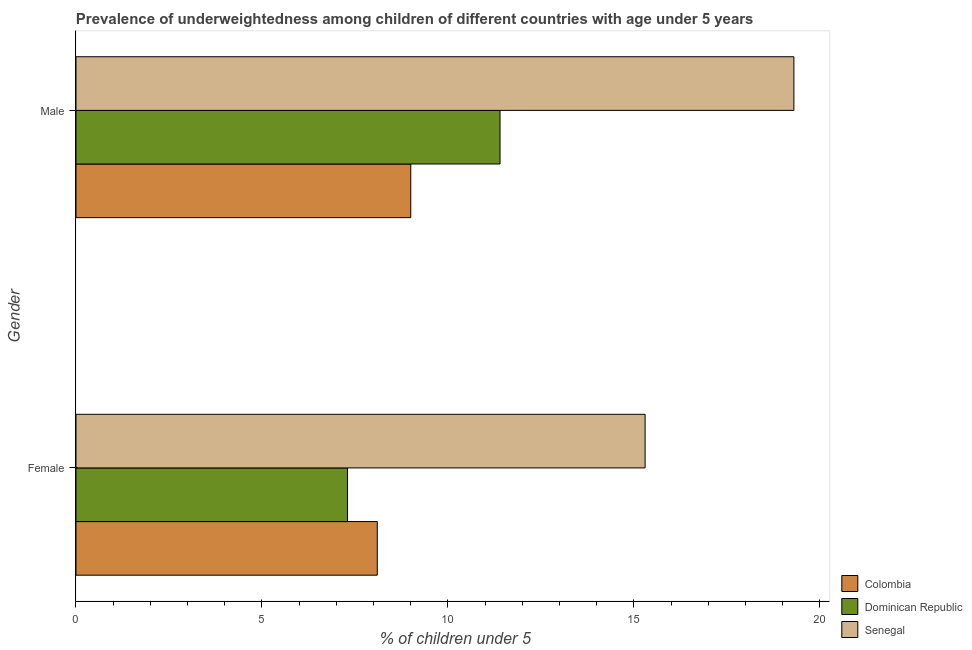How many different coloured bars are there?
Your answer should be very brief. 3. How many groups of bars are there?
Offer a terse response. 2. What is the label of the 2nd group of bars from the top?
Keep it short and to the point. Female. What is the percentage of underweighted male children in Dominican Republic?
Your answer should be very brief. 11.4. Across all countries, what is the maximum percentage of underweighted female children?
Provide a succinct answer. 15.3. Across all countries, what is the minimum percentage of underweighted male children?
Your answer should be very brief. 9. In which country was the percentage of underweighted male children maximum?
Your response must be concise. Senegal. In which country was the percentage of underweighted male children minimum?
Ensure brevity in your answer.  Colombia. What is the total percentage of underweighted male children in the graph?
Ensure brevity in your answer.  39.7. What is the difference between the percentage of underweighted male children in Dominican Republic and that in Colombia?
Make the answer very short. 2.4. What is the difference between the percentage of underweighted male children in Senegal and the percentage of underweighted female children in Dominican Republic?
Provide a short and direct response. 12. What is the average percentage of underweighted male children per country?
Provide a succinct answer. 13.23. What is the difference between the percentage of underweighted male children and percentage of underweighted female children in Senegal?
Keep it short and to the point. 4. In how many countries, is the percentage of underweighted male children greater than 12 %?
Provide a short and direct response. 1. What is the ratio of the percentage of underweighted male children in Senegal to that in Colombia?
Give a very brief answer. 2.14. Is the percentage of underweighted male children in Colombia less than that in Dominican Republic?
Provide a short and direct response. Yes. In how many countries, is the percentage of underweighted female children greater than the average percentage of underweighted female children taken over all countries?
Offer a terse response. 1. What does the 3rd bar from the top in Female represents?
Your answer should be compact. Colombia. What does the 3rd bar from the bottom in Male represents?
Give a very brief answer. Senegal. How many countries are there in the graph?
Offer a very short reply. 3. Does the graph contain any zero values?
Offer a terse response. No. Does the graph contain grids?
Your response must be concise. No. Where does the legend appear in the graph?
Your answer should be very brief. Bottom right. How many legend labels are there?
Keep it short and to the point. 3. How are the legend labels stacked?
Offer a very short reply. Vertical. What is the title of the graph?
Your answer should be very brief. Prevalence of underweightedness among children of different countries with age under 5 years. What is the label or title of the X-axis?
Provide a succinct answer.  % of children under 5. What is the label or title of the Y-axis?
Your answer should be compact. Gender. What is the  % of children under 5 of Colombia in Female?
Your response must be concise. 8.1. What is the  % of children under 5 in Dominican Republic in Female?
Keep it short and to the point. 7.3. What is the  % of children under 5 of Senegal in Female?
Offer a very short reply. 15.3. What is the  % of children under 5 in Colombia in Male?
Your response must be concise. 9. What is the  % of children under 5 of Dominican Republic in Male?
Ensure brevity in your answer.  11.4. What is the  % of children under 5 of Senegal in Male?
Keep it short and to the point. 19.3. Across all Gender, what is the maximum  % of children under 5 in Dominican Republic?
Your response must be concise. 11.4. Across all Gender, what is the maximum  % of children under 5 in Senegal?
Keep it short and to the point. 19.3. Across all Gender, what is the minimum  % of children under 5 of Colombia?
Give a very brief answer. 8.1. Across all Gender, what is the minimum  % of children under 5 of Dominican Republic?
Keep it short and to the point. 7.3. Across all Gender, what is the minimum  % of children under 5 in Senegal?
Your answer should be compact. 15.3. What is the total  % of children under 5 in Dominican Republic in the graph?
Keep it short and to the point. 18.7. What is the total  % of children under 5 of Senegal in the graph?
Make the answer very short. 34.6. What is the difference between the  % of children under 5 of Colombia in Female and that in Male?
Offer a terse response. -0.9. What is the difference between the  % of children under 5 of Senegal in Female and that in Male?
Your answer should be compact. -4. What is the difference between the  % of children under 5 in Colombia in Female and the  % of children under 5 in Dominican Republic in Male?
Make the answer very short. -3.3. What is the difference between the  % of children under 5 of Colombia in Female and the  % of children under 5 of Senegal in Male?
Provide a succinct answer. -11.2. What is the difference between the  % of children under 5 in Dominican Republic in Female and the  % of children under 5 in Senegal in Male?
Your response must be concise. -12. What is the average  % of children under 5 in Colombia per Gender?
Make the answer very short. 8.55. What is the average  % of children under 5 in Dominican Republic per Gender?
Offer a very short reply. 9.35. What is the difference between the  % of children under 5 in Colombia and  % of children under 5 in Dominican Republic in Female?
Ensure brevity in your answer.  0.8. What is the difference between the  % of children under 5 in Colombia and  % of children under 5 in Senegal in Female?
Your answer should be very brief. -7.2. What is the difference between the  % of children under 5 in Colombia and  % of children under 5 in Dominican Republic in Male?
Provide a succinct answer. -2.4. What is the ratio of the  % of children under 5 in Colombia in Female to that in Male?
Provide a short and direct response. 0.9. What is the ratio of the  % of children under 5 of Dominican Republic in Female to that in Male?
Give a very brief answer. 0.64. What is the ratio of the  % of children under 5 of Senegal in Female to that in Male?
Keep it short and to the point. 0.79. What is the difference between the highest and the second highest  % of children under 5 in Dominican Republic?
Your response must be concise. 4.1. What is the difference between the highest and the second highest  % of children under 5 of Senegal?
Provide a succinct answer. 4. What is the difference between the highest and the lowest  % of children under 5 of Colombia?
Make the answer very short. 0.9. 